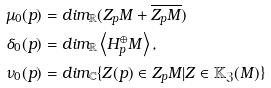<formula> <loc_0><loc_0><loc_500><loc_500>\mu _ { 0 } ( p ) & = d i m _ { \mathbb { R } } ( Z _ { p } M + \overline { Z _ { p } M } ) \\ \delta _ { 0 } ( { p } ) & = d i m _ { \mathbb { R } } \left \langle H ^ { \oplus } _ { p } M \right \rangle , \\ \nu _ { 0 } ( p ) & = d i m _ { \mathbb { C } } \{ Z ( p ) \in { Z } _ { p } M | Z \in \mathbb { K } _ { \mathfrak { Z } } ( M ) \}</formula> 